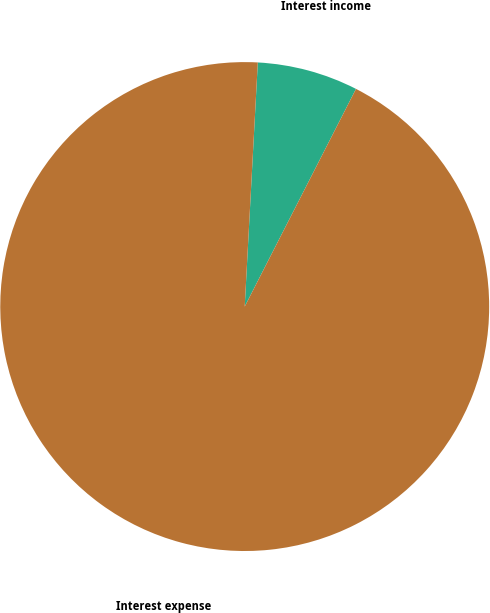Convert chart to OTSL. <chart><loc_0><loc_0><loc_500><loc_500><pie_chart><fcel>Interest income<fcel>Interest expense<nl><fcel>6.67%<fcel>93.33%<nl></chart> 